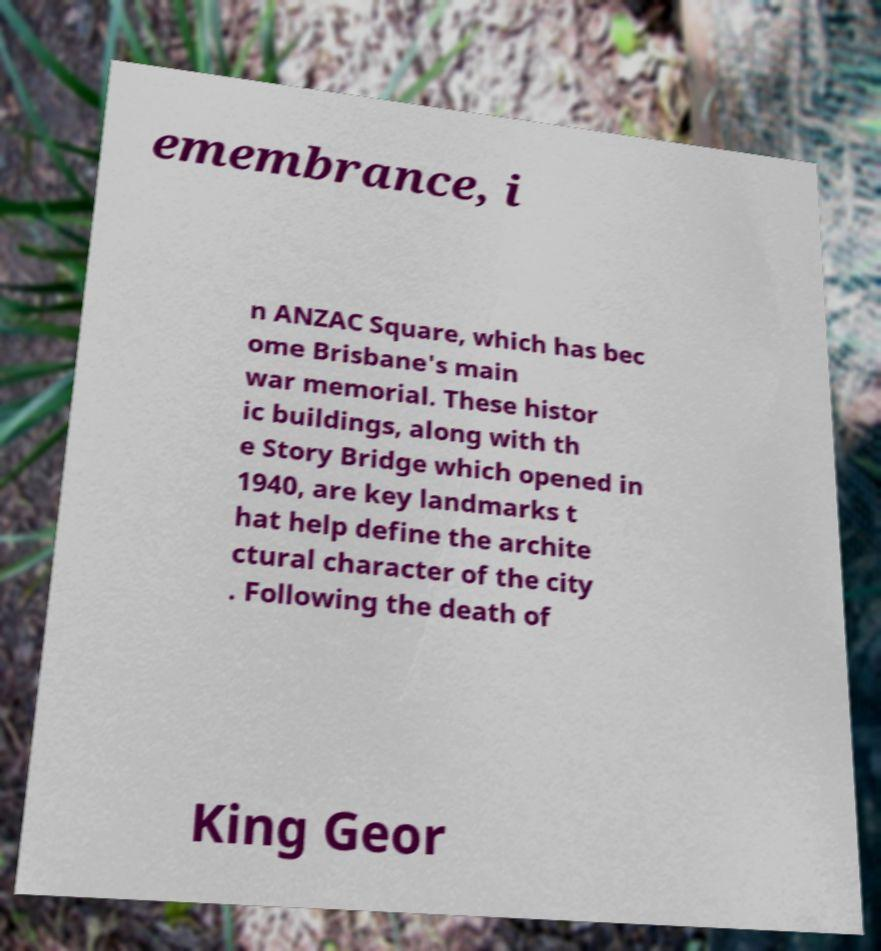Can you accurately transcribe the text from the provided image for me? emembrance, i n ANZAC Square, which has bec ome Brisbane's main war memorial. These histor ic buildings, along with th e Story Bridge which opened in 1940, are key landmarks t hat help define the archite ctural character of the city . Following the death of King Geor 